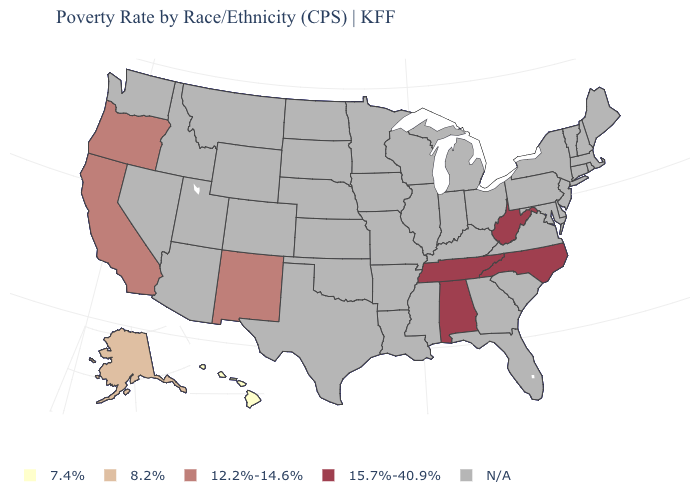Name the states that have a value in the range 15.7%-40.9%?
Write a very short answer. Alabama, North Carolina, Tennessee, West Virginia. What is the value of Arkansas?
Short answer required. N/A. What is the value of Minnesota?
Concise answer only. N/A. What is the value of Vermont?
Short answer required. N/A. Does the first symbol in the legend represent the smallest category?
Write a very short answer. Yes. What is the highest value in the USA?
Quick response, please. 15.7%-40.9%. What is the value of Connecticut?
Quick response, please. N/A. Name the states that have a value in the range 8.2%?
Answer briefly. Alaska. 